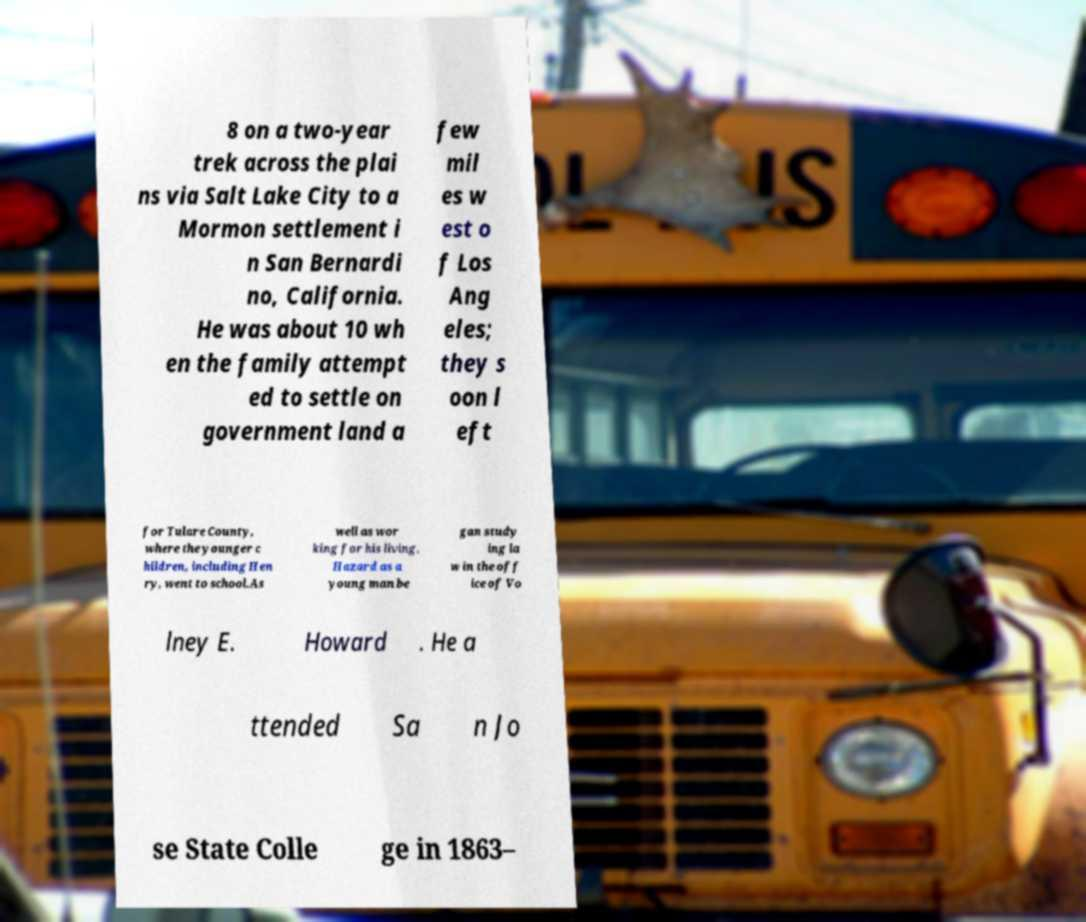I need the written content from this picture converted into text. Can you do that? 8 on a two-year trek across the plai ns via Salt Lake City to a Mormon settlement i n San Bernardi no, California. He was about 10 wh en the family attempt ed to settle on government land a few mil es w est o f Los Ang eles; they s oon l eft for Tulare County, where the younger c hildren, including Hen ry, went to school.As well as wor king for his living, Hazard as a young man be gan study ing la w in the off ice of Vo lney E. Howard . He a ttended Sa n Jo se State Colle ge in 1863– 